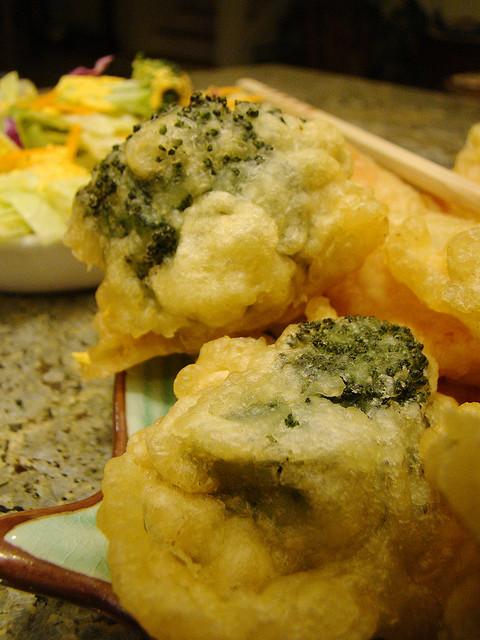How many knives are there?
Write a very short answer. 0. Is there a salad in the picture?
Be succinct. No. Have the eggs been cooked?
Concise answer only. Yes. What kind of food is this?
Quick response, please. Broccoli. Would a vegan eat this?
Be succinct. Yes. What is yellow on the food?
Give a very brief answer. Cheese. What is on top of the pasta?
Give a very brief answer. Broccoli. What shape is the food?
Write a very short answer. Round. What meal is being eaten?
Quick response, please. Broccoli. Would a vegetarian  like this meal?
Be succinct. Yes. Has the cheese been melted?
Concise answer only. Yes. Where is the plate?
Short answer required. Under food. Is this a pizza?
Concise answer only. No. Which snack is this?
Be succinct. Fried broccoli. What is color of the broccoli?
Quick response, please. Green. 